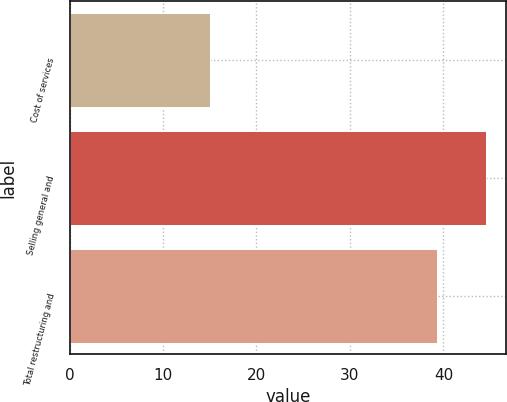Convert chart to OTSL. <chart><loc_0><loc_0><loc_500><loc_500><bar_chart><fcel>Cost of services<fcel>Selling general and<fcel>Total restructuring and<nl><fcel>15<fcel>44.5<fcel>39.3<nl></chart> 